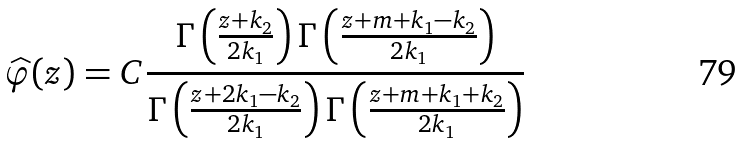Convert formula to latex. <formula><loc_0><loc_0><loc_500><loc_500>\widehat { \varphi } ( z ) = C \frac { \Gamma \left ( \frac { z + k _ { 2 } } { 2 k _ { 1 } } \right ) \Gamma \left ( \frac { z + m + k _ { 1 } - k _ { 2 } } { 2 k _ { 1 } } \right ) } { \Gamma \left ( \frac { z + 2 k _ { 1 } - k _ { 2 } } { 2 k _ { 1 } } \right ) \Gamma \left ( \frac { z + m + k _ { 1 } + k _ { 2 } } { 2 k _ { 1 } } \right ) }</formula> 